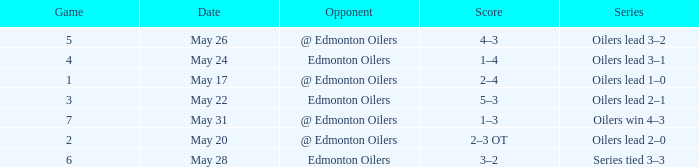Series of oilers win 4–3 had what highest game? 7.0. 